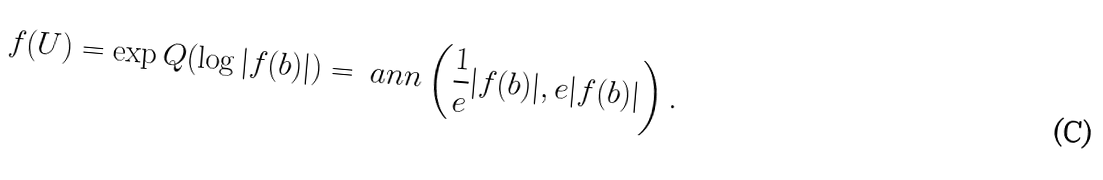<formula> <loc_0><loc_0><loc_500><loc_500>f ( U ) = \exp Q ( \log | f ( b ) | ) = \ a n n \left ( \frac { 1 } { e } | f ( b ) | , e | f ( b ) | \right ) .</formula> 